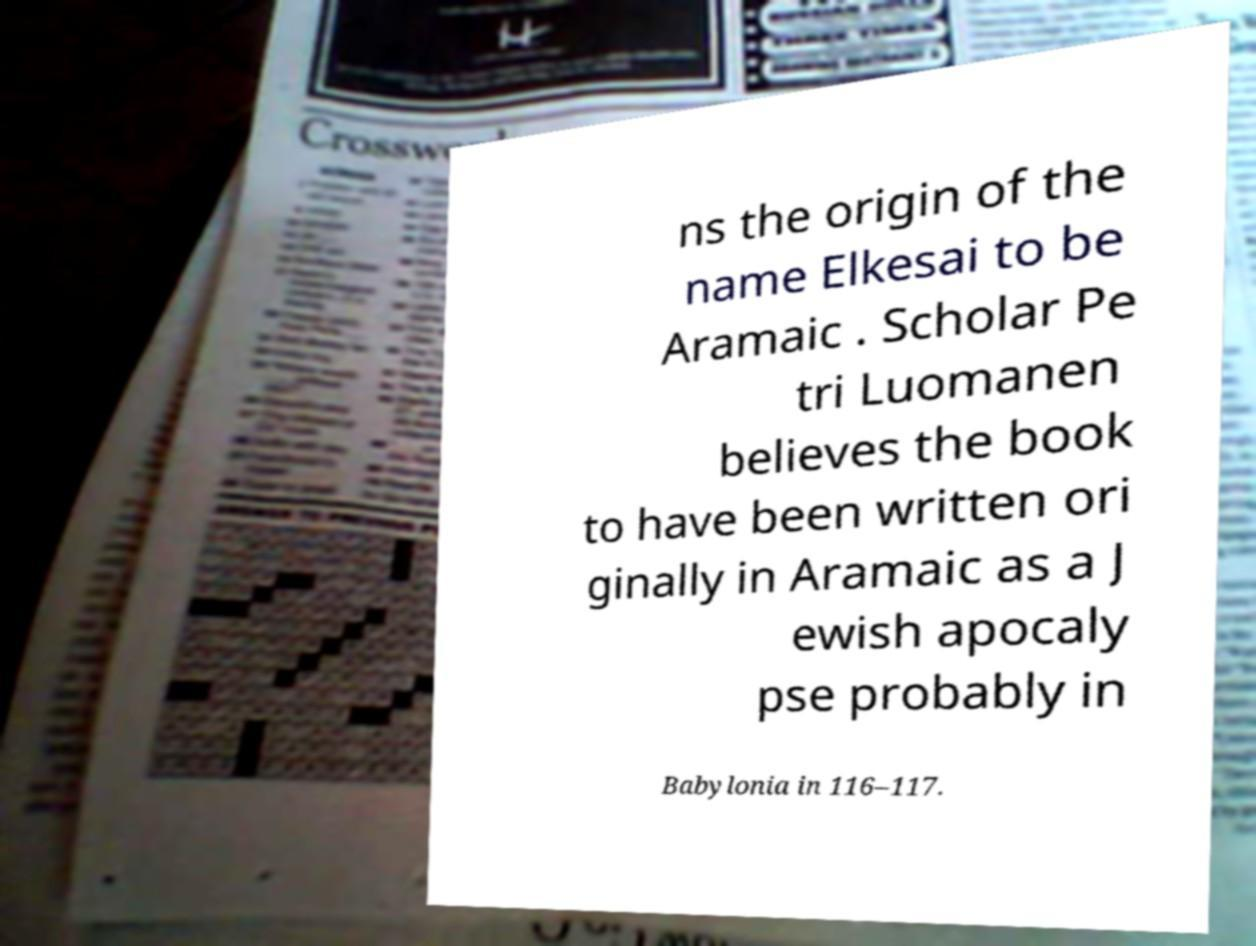For documentation purposes, I need the text within this image transcribed. Could you provide that? ns the origin of the name Elkesai to be Aramaic . Scholar Pe tri Luomanen believes the book to have been written ori ginally in Aramaic as a J ewish apocaly pse probably in Babylonia in 116–117. 